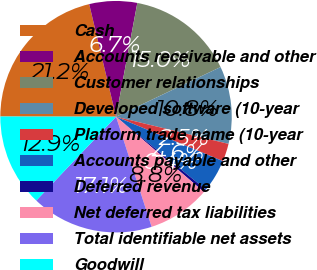Convert chart. <chart><loc_0><loc_0><loc_500><loc_500><pie_chart><fcel>Cash<fcel>Accounts receivable and other<fcel>Customer relationships<fcel>Developed software (10-year<fcel>Platform trade name (10-year<fcel>Accounts payable and other<fcel>Deferred revenue<fcel>Net deferred tax liabilities<fcel>Total identifiable net assets<fcel>Goodwill<nl><fcel>21.25%<fcel>6.67%<fcel>15.0%<fcel>10.83%<fcel>2.5%<fcel>4.58%<fcel>0.42%<fcel>8.75%<fcel>17.08%<fcel>12.92%<nl></chart> 